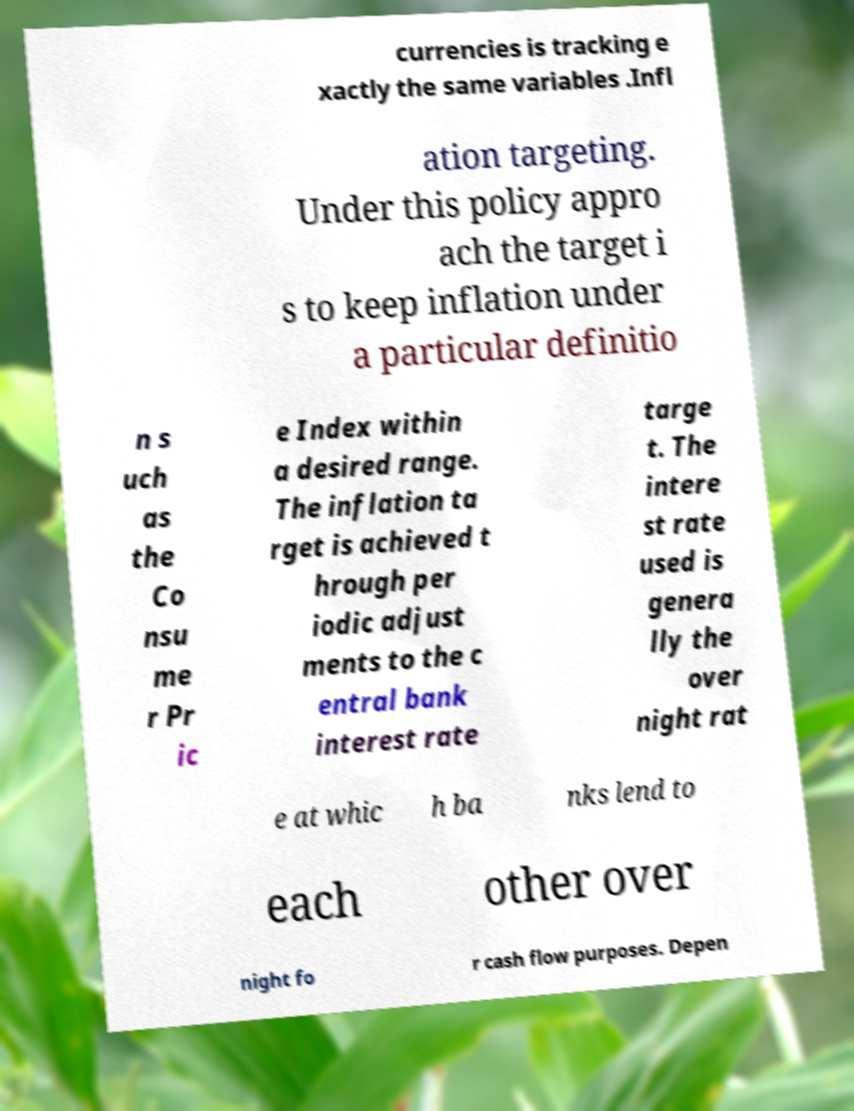Could you assist in decoding the text presented in this image and type it out clearly? currencies is tracking e xactly the same variables .Infl ation targeting. Under this policy appro ach the target i s to keep inflation under a particular definitio n s uch as the Co nsu me r Pr ic e Index within a desired range. The inflation ta rget is achieved t hrough per iodic adjust ments to the c entral bank interest rate targe t. The intere st rate used is genera lly the over night rat e at whic h ba nks lend to each other over night fo r cash flow purposes. Depen 